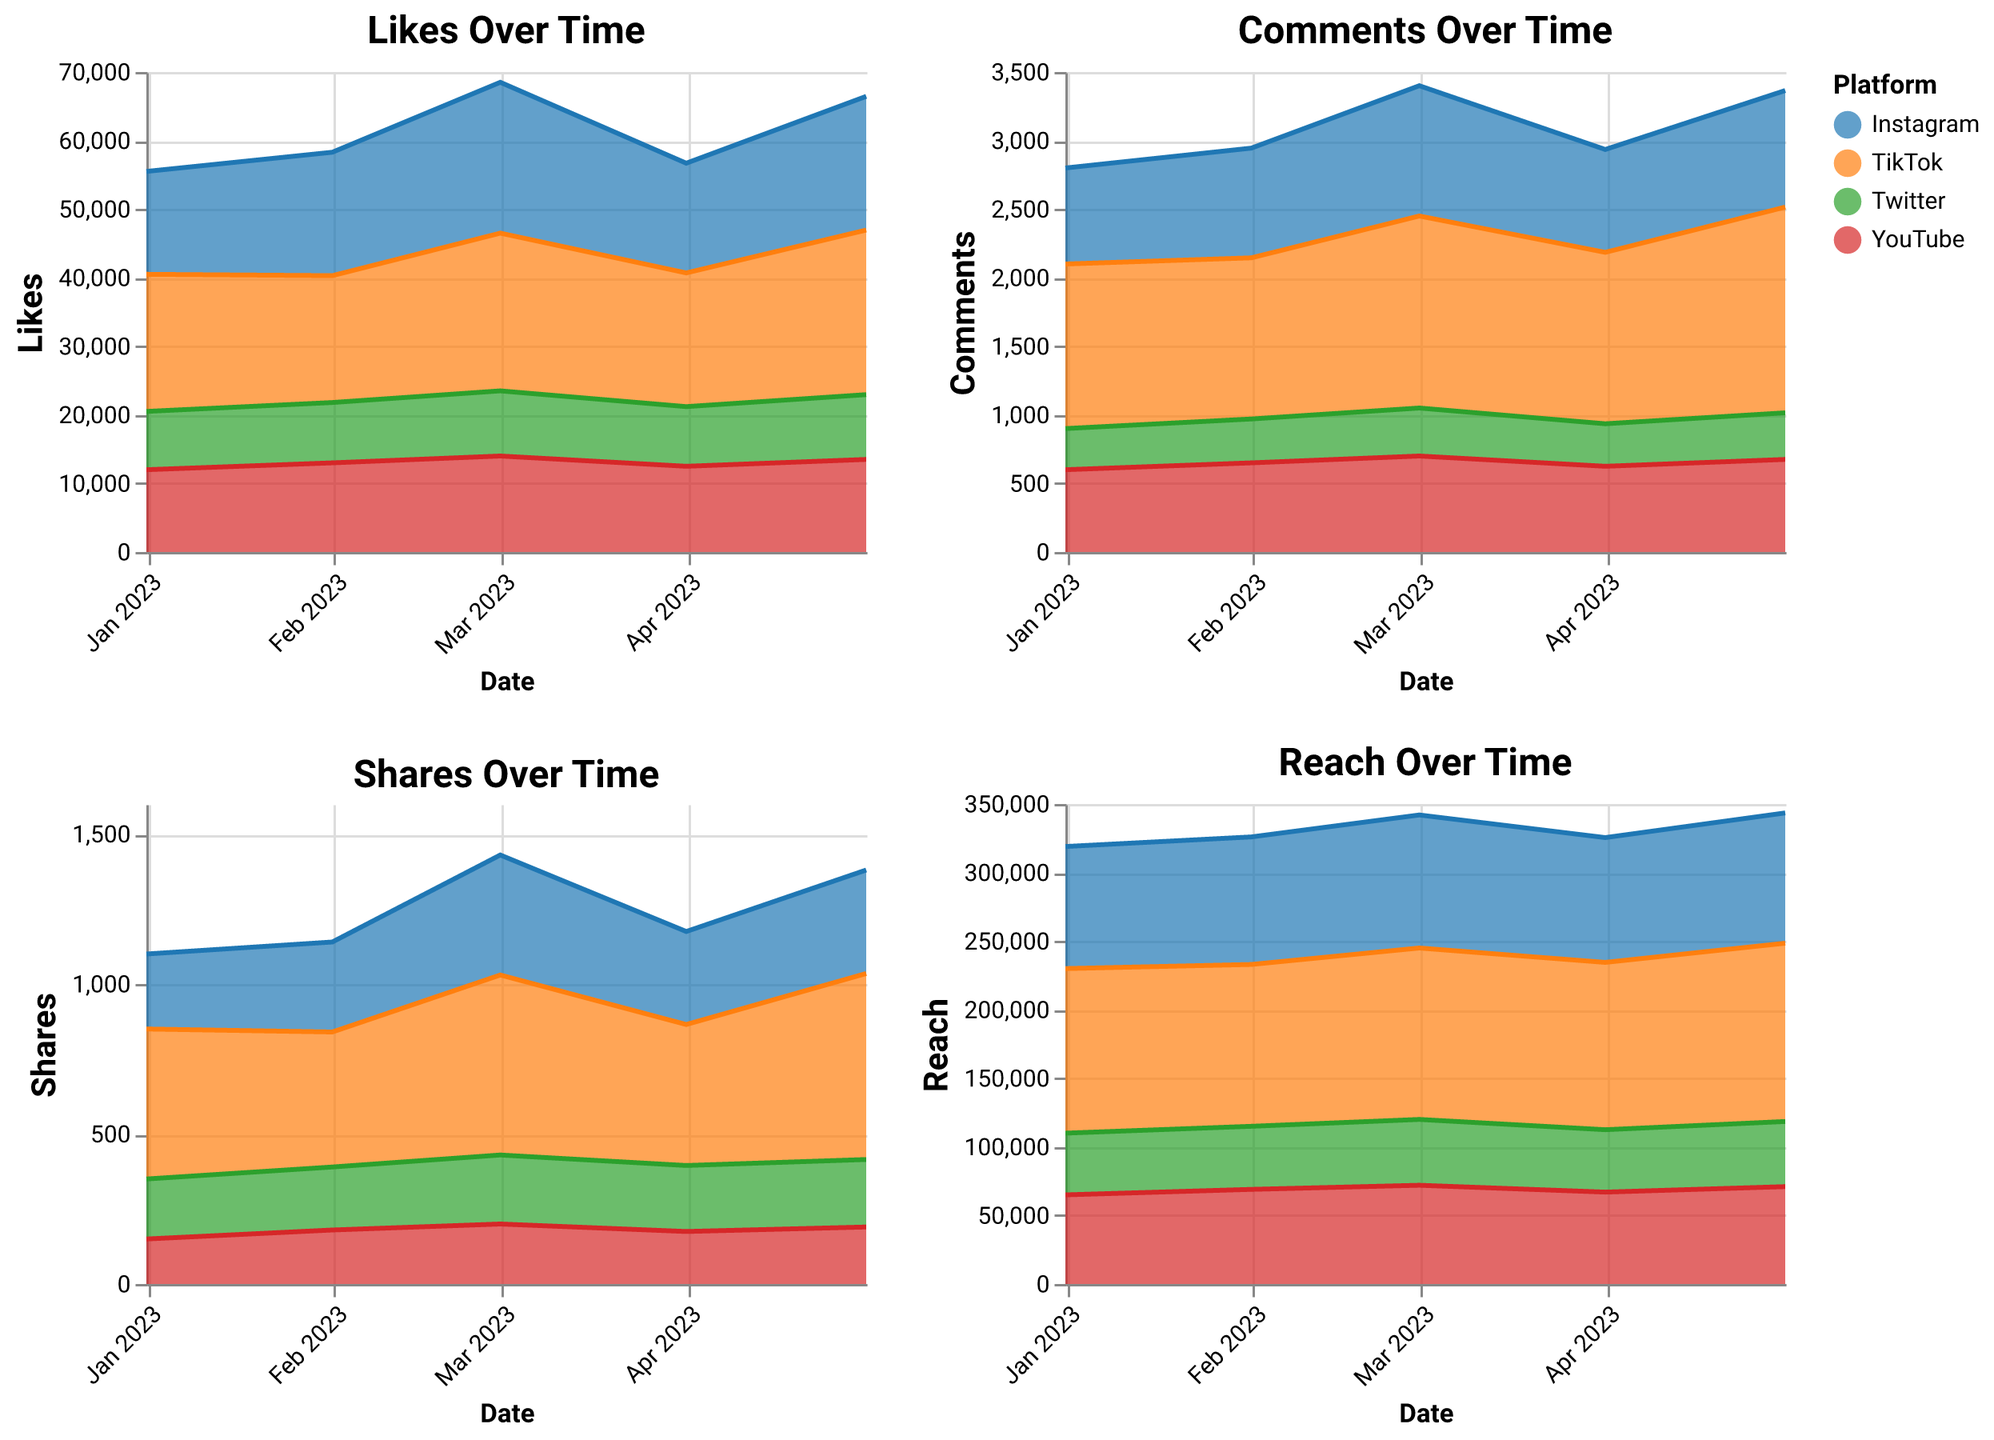What's the total reach across all platforms in January 2023? To calculate the total reach, sum the reach values for each platform: Instagram (89000), TikTok (120000), Twitter (45000), and YouTube (65000). 89000 + 120000 + 45000 + 65000 = 319000.
Answer: 319000 Which platform saw the highest number of likes in March 2023? Compare the likes in March 2023 for each platform: Instagram (22000), TikTok (23000), Twitter (9500), and YouTube (14000). TikTok has the highest with 23000 likes.
Answer: TikTok How did the total number of comments on Instagram change from January to March 2023? For January, Instagram had 700 comments. For March, this increased to 950 comments. The change is 950 - 700 = 250.
Answer: Increased by 250 What is the trend of shares for YouTube over the period? Observe the shares for YouTube from January to May: 150, 180, 200, 175, and 190. It increases from January to March, then decreases in April, and slightly increases again in May.
Answer: An increasing trend with minor fluctuations Which platform had the lowest reach in May 2023? Compare the reach values in May 2023: Instagram (95000), TikTok (130000), Twitter (47500), and YouTube (71000). Twitter has the lowest reach with 47500.
Answer: Twitter How do TikTok's comments in April 2023 compare to Twitter's comments in the same month? For April 2023, TikTok had 1250 comments, while Twitter had 310 comments. TikTok's comments are significantly higher than Twitter's.
Answer: TikTok's comments are higher What was the difference in TikTok's reach between April and May 2023? TikTok's reach in April 2023 was 122000 and in May 2023, it was 130000. The difference is 130000 - 122000 = 8000.
Answer: 8000 What is the overall trend for Instagram's likes over the period? Check the likes for Instagram from January to May: 15000, 18000, 22000, 16000, and 19500. The general trend shows a fluctuating pattern with an overall increase.
Answer: Fluctuating with overall increase 